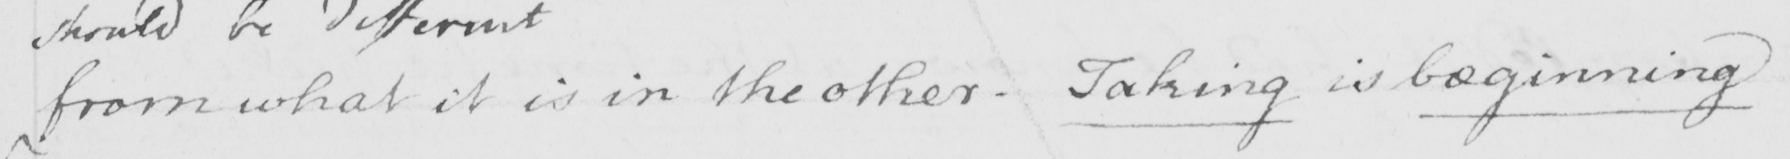What text is written in this handwritten line? from what it is in the other . Taking is beginning 